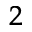Convert formula to latex. <formula><loc_0><loc_0><loc_500><loc_500>^ { 2 }</formula> 